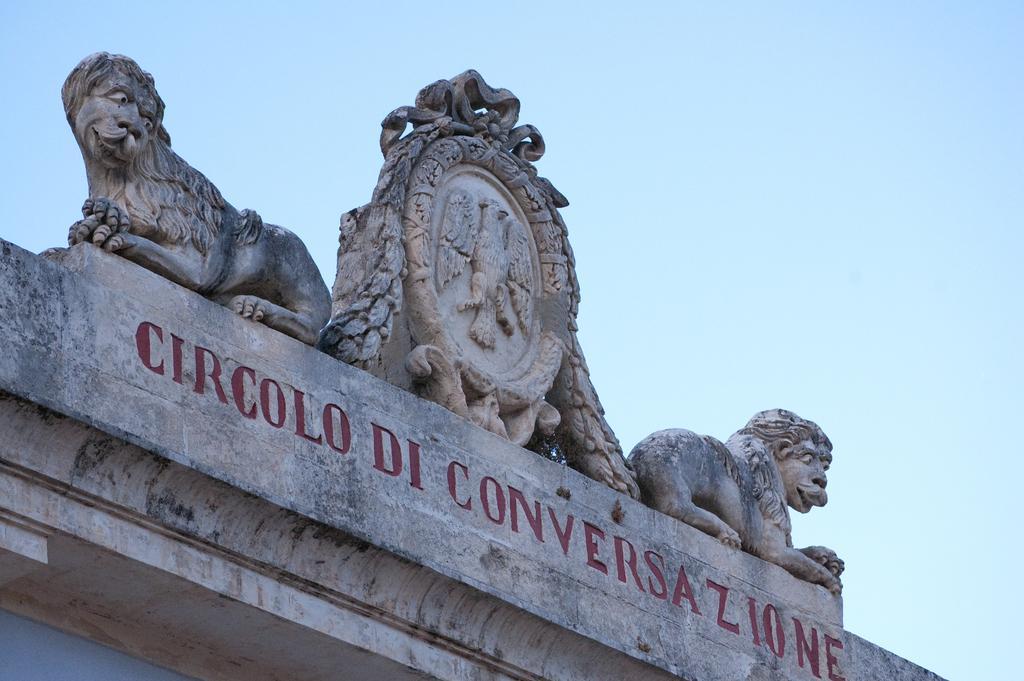Please provide a concise description of this image. In this image there are two lion statues on top of a building with some text engraved on the wall. 